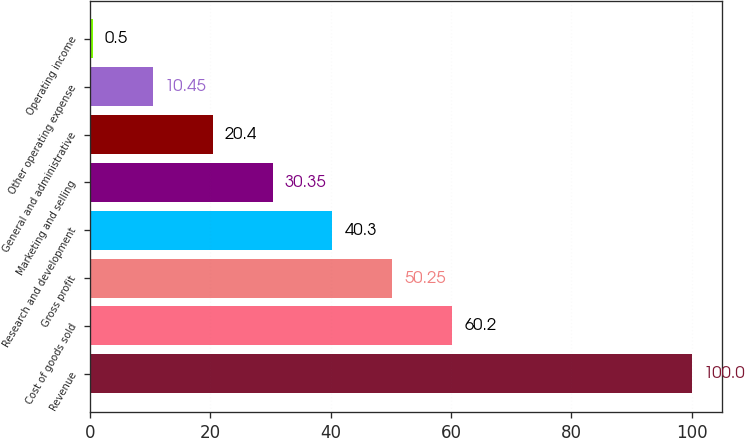Convert chart. <chart><loc_0><loc_0><loc_500><loc_500><bar_chart><fcel>Revenue<fcel>Cost of goods sold<fcel>Gross profit<fcel>Research and development<fcel>Marketing and selling<fcel>General and administrative<fcel>Other operating expense<fcel>Operating income<nl><fcel>100<fcel>60.2<fcel>50.25<fcel>40.3<fcel>30.35<fcel>20.4<fcel>10.45<fcel>0.5<nl></chart> 